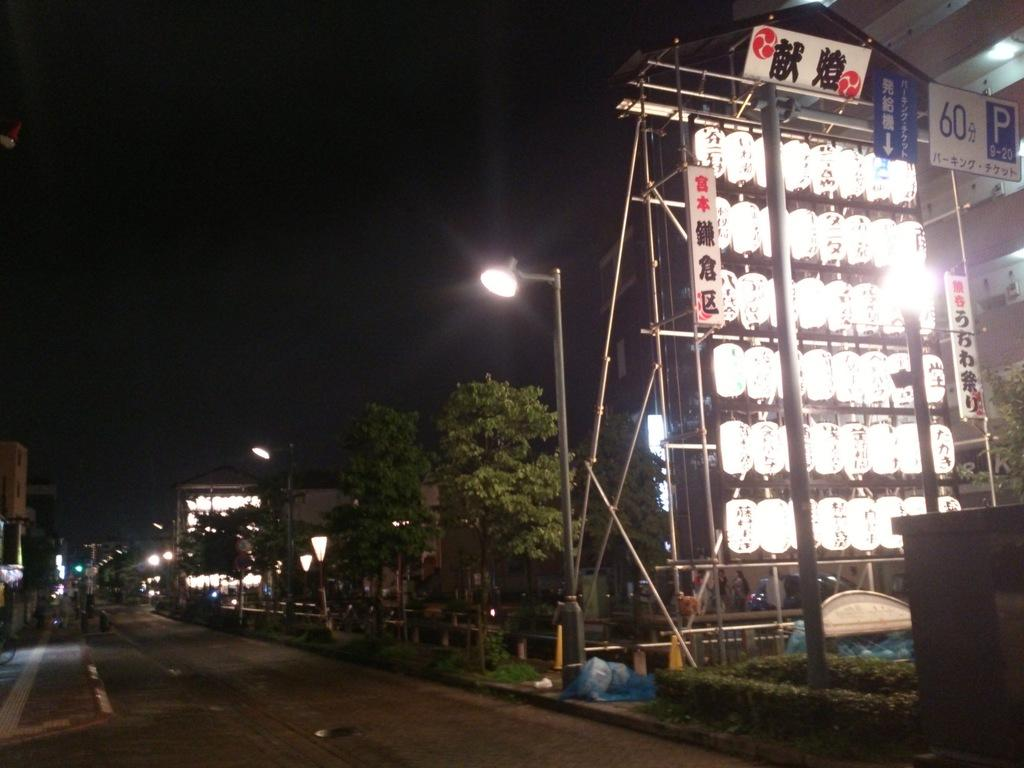<image>
Relay a brief, clear account of the picture shown. "60" and "P 9-20" can be seen in the upper corner of a bank of lights near a dark street. 